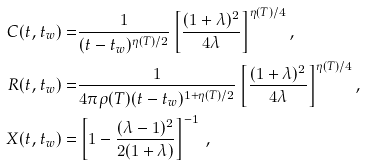Convert formula to latex. <formula><loc_0><loc_0><loc_500><loc_500>C ( t , t _ { w } ) = & \frac { 1 } { ( t - t _ { w } ) ^ { \eta ( T ) / 2 } } \left [ \frac { ( 1 + \lambda ) ^ { 2 } } { 4 \lambda } \right ] ^ { \eta ( T ) / 4 } , \\ R ( t , t _ { w } ) = & \frac { 1 } { 4 \pi \rho ( T ) ( t - t _ { w } ) ^ { 1 + \eta ( T ) / 2 } } \left [ \frac { ( 1 + \lambda ) ^ { 2 } } { 4 \lambda } \right ] ^ { \eta ( T ) / 4 } , \\ X ( t , t _ { w } ) = & \left [ 1 - \frac { ( \lambda - 1 ) ^ { 2 } } { 2 ( 1 + \lambda ) } \right ] ^ { - 1 } \, ,</formula> 